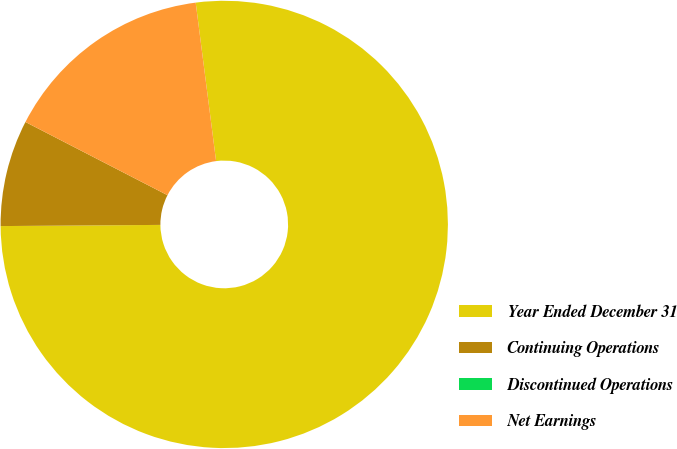Convert chart. <chart><loc_0><loc_0><loc_500><loc_500><pie_chart><fcel>Year Ended December 31<fcel>Continuing Operations<fcel>Discontinued Operations<fcel>Net Earnings<nl><fcel>76.92%<fcel>7.69%<fcel>0.0%<fcel>15.39%<nl></chart> 